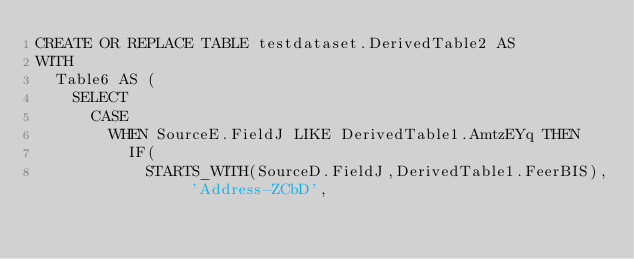<code> <loc_0><loc_0><loc_500><loc_500><_SQL_>CREATE OR REPLACE TABLE testdataset.DerivedTable2 AS
WITH
  Table6 AS (
    SELECT
      CASE
        WHEN SourceE.FieldJ LIKE DerivedTable1.AmtzEYq THEN
          IF(
            STARTS_WITH(SourceD.FieldJ,DerivedTable1.FeerBIS), 'Address-ZCbD',</code> 